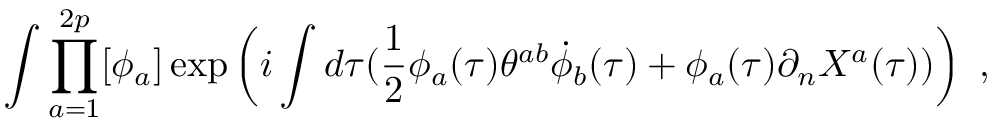Convert formula to latex. <formula><loc_0><loc_0><loc_500><loc_500>\int \prod _ { a = 1 } ^ { 2 p } [ \phi _ { a } ] \exp \left ( i \int d \tau ( \frac { 1 } { 2 } \phi _ { a } ( \tau ) \theta ^ { a b } \dot { \phi } _ { b } ( \tau ) + \phi _ { a } ( \tau ) \partial _ { n } X ^ { a } ( \tau ) ) \right ) \ ,</formula> 